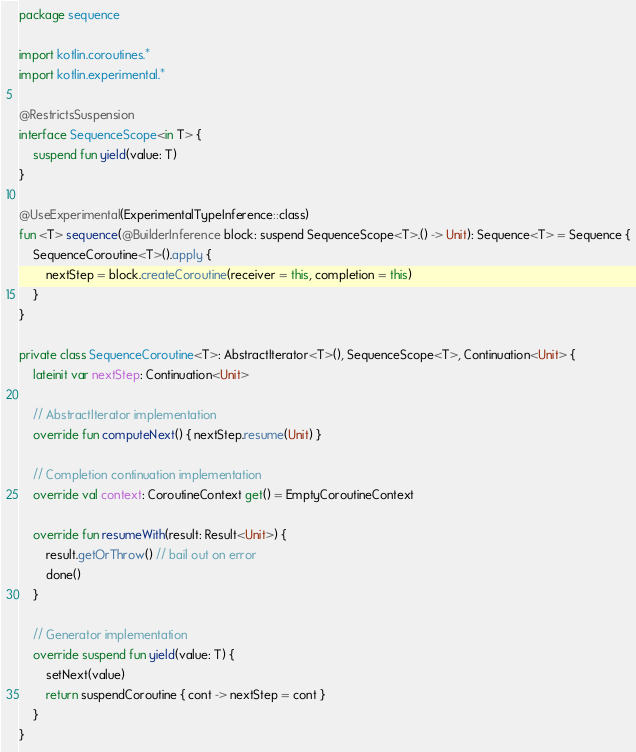<code> <loc_0><loc_0><loc_500><loc_500><_Kotlin_>package sequence

import kotlin.coroutines.*
import kotlin.experimental.*

@RestrictsSuspension
interface SequenceScope<in T> {
    suspend fun yield(value: T)
}

@UseExperimental(ExperimentalTypeInference::class)
fun <T> sequence(@BuilderInference block: suspend SequenceScope<T>.() -> Unit): Sequence<T> = Sequence {
    SequenceCoroutine<T>().apply {
        nextStep = block.createCoroutine(receiver = this, completion = this)
    }
}

private class SequenceCoroutine<T>: AbstractIterator<T>(), SequenceScope<T>, Continuation<Unit> {
    lateinit var nextStep: Continuation<Unit>

    // AbstractIterator implementation
    override fun computeNext() { nextStep.resume(Unit) }

    // Completion continuation implementation
    override val context: CoroutineContext get() = EmptyCoroutineContext

    override fun resumeWith(result: Result<Unit>) {
        result.getOrThrow() // bail out on error
        done()
    }

    // Generator implementation
    override suspend fun yield(value: T) {
        setNext(value)
        return suspendCoroutine { cont -> nextStep = cont }
    }
}
</code> 